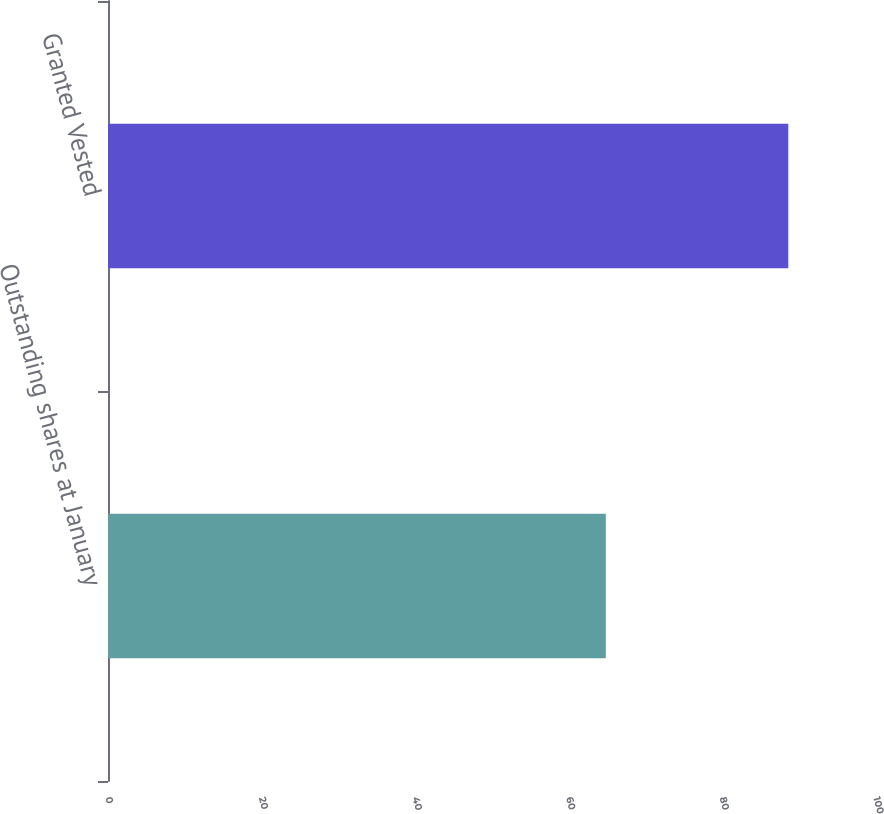Convert chart to OTSL. <chart><loc_0><loc_0><loc_500><loc_500><bar_chart><fcel>Outstanding shares at January<fcel>Granted Vested<nl><fcel>64.82<fcel>88.58<nl></chart> 